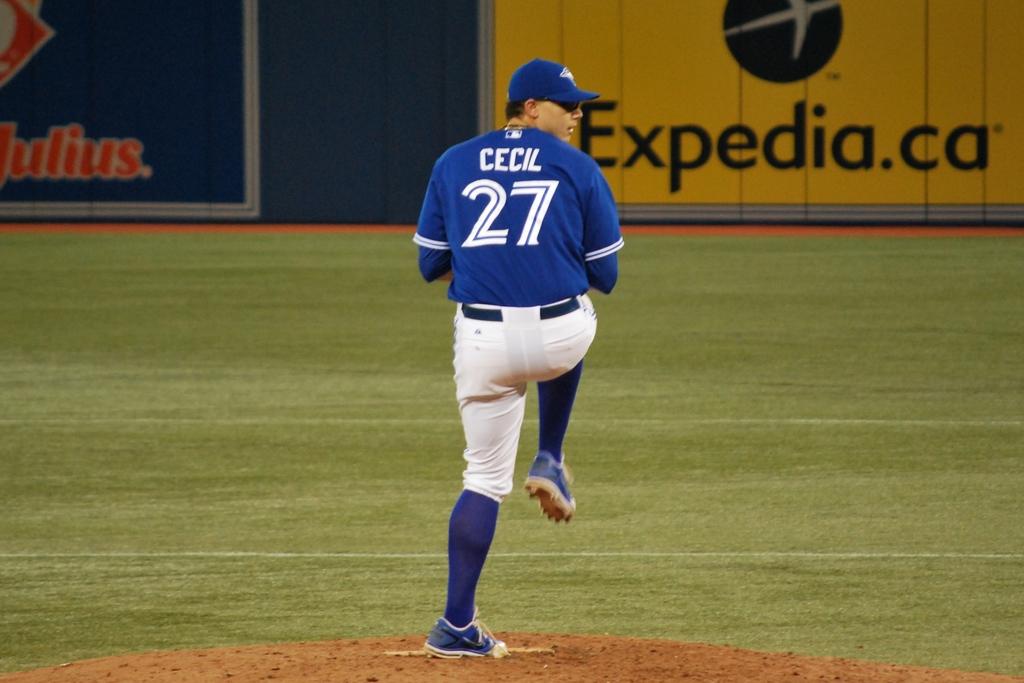Who is number 27?
Make the answer very short. Cecil. Which company is advertising on the yellow sign?
Offer a very short reply. Expedia. 